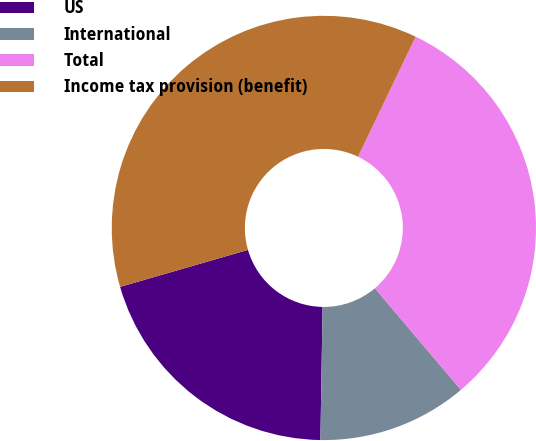Convert chart. <chart><loc_0><loc_0><loc_500><loc_500><pie_chart><fcel>US<fcel>International<fcel>Total<fcel>Income tax provision (benefit)<nl><fcel>20.26%<fcel>11.44%<fcel>31.7%<fcel>36.6%<nl></chart> 